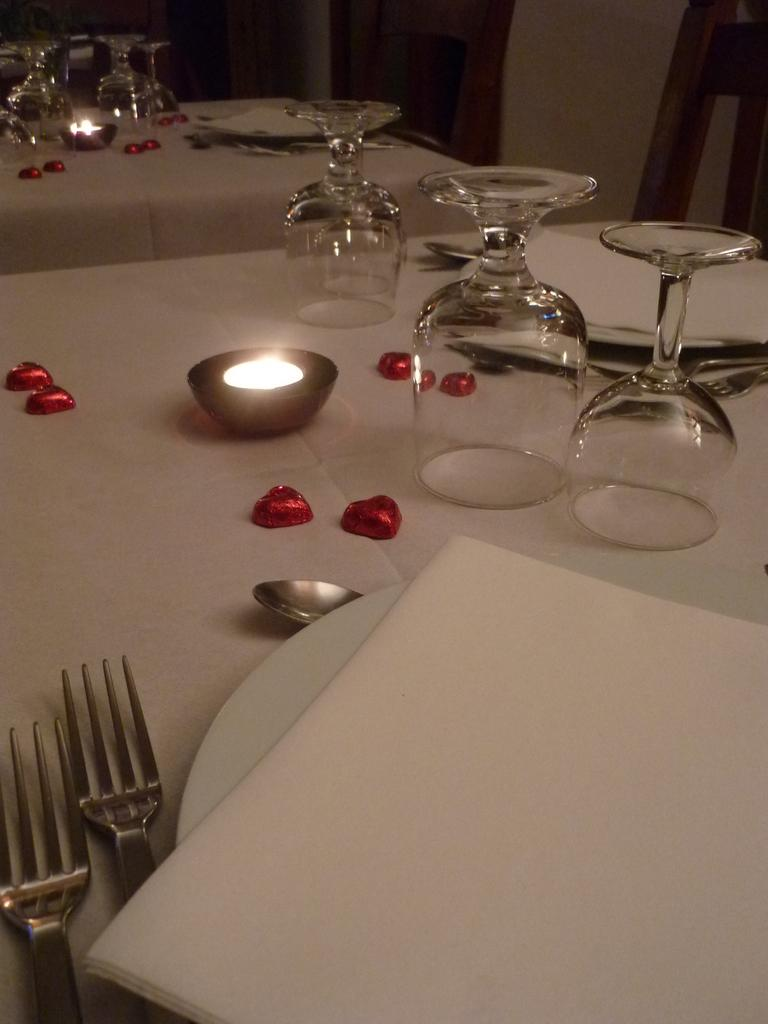What type of furniture is visible in the image? There are tables in the image. What items can be seen on the tables? Clothes, glasses, plates, tissue papers, spoons, and forks are on the tables. What is the purpose of the tissue papers on the tables? The tissue papers might be used for wiping or cleaning purposes. What can be seen in the background of the image? There are chairs in the background of the image. Can you smell the lake in the image? There is no lake present in the image, so it is not possible to smell it. 